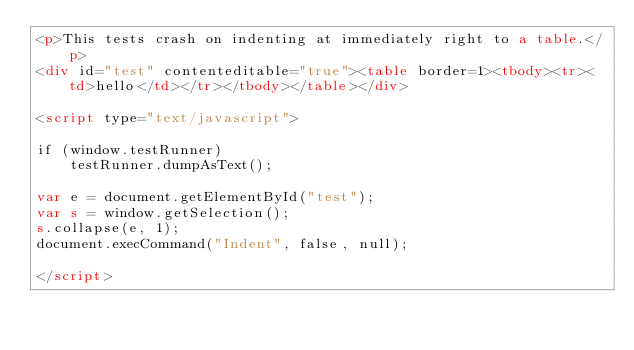Convert code to text. <code><loc_0><loc_0><loc_500><loc_500><_HTML_><p>This tests crash on indenting at immediately right to a table.</p>
<div id="test" contenteditable="true"><table border=1><tbody><tr><td>hello</td></tr></tbody></table></div>

<script type="text/javascript">

if (window.testRunner)
    testRunner.dumpAsText();

var e = document.getElementById("test");
var s = window.getSelection();
s.collapse(e, 1);
document.execCommand("Indent", false, null);

</script>
</code> 